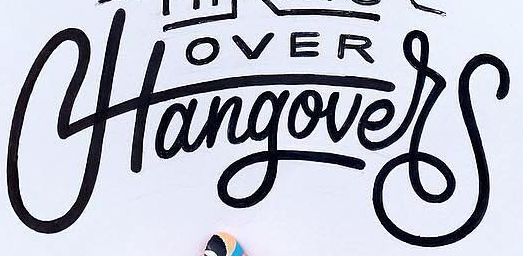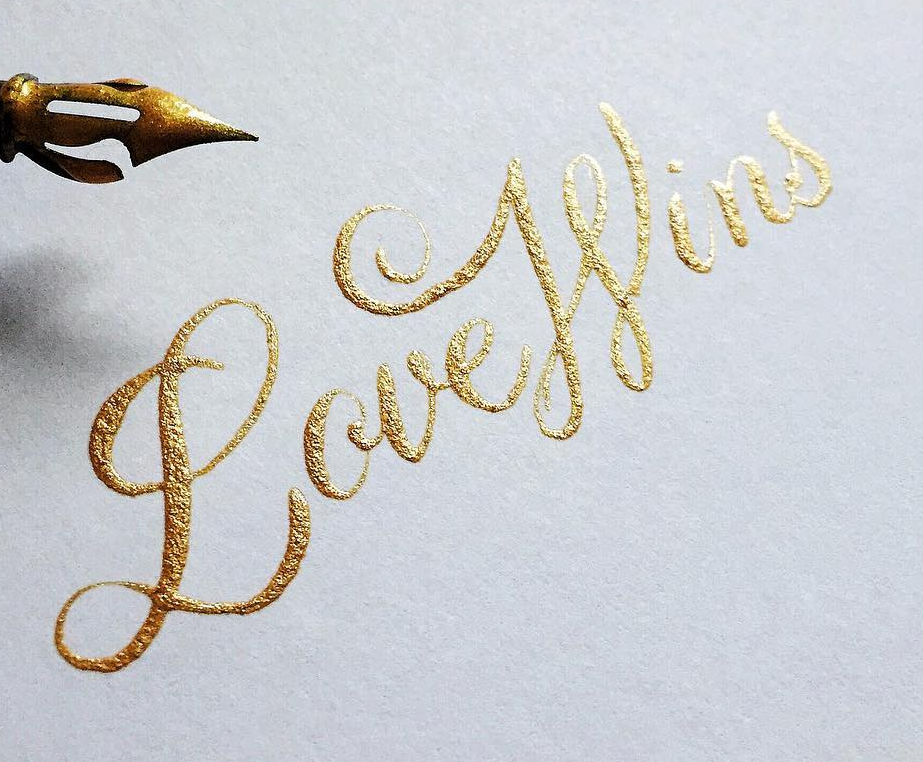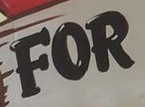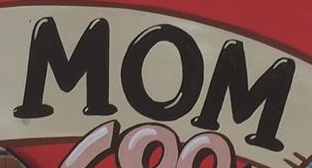Identify the words shown in these images in order, separated by a semicolon. Hangover; LoveWins; FOR; MOM 